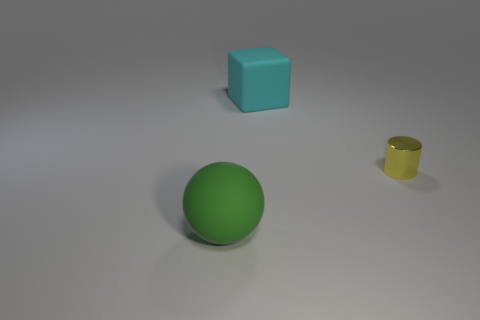Is the number of yellow things greater than the number of rubber things? no 